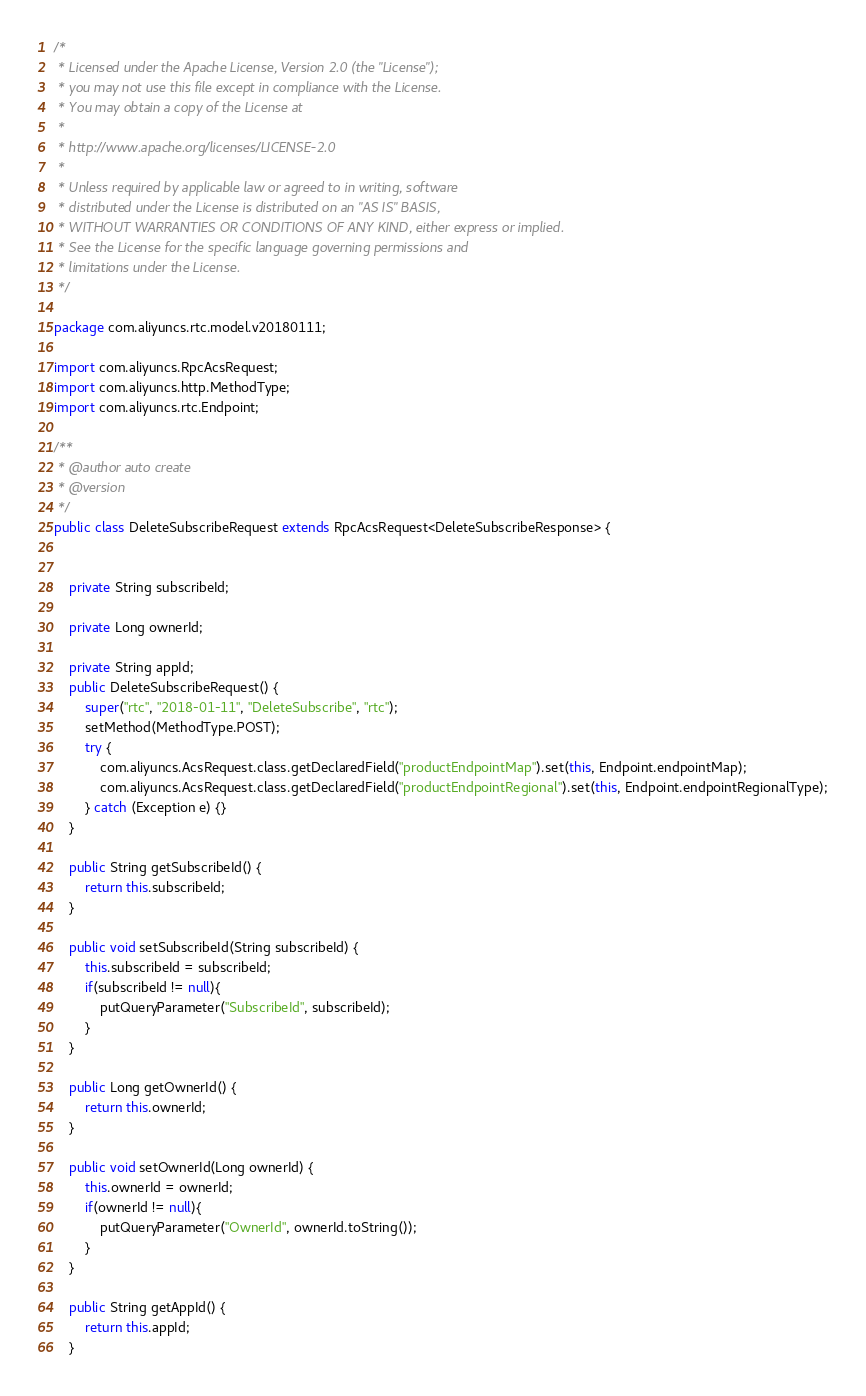Convert code to text. <code><loc_0><loc_0><loc_500><loc_500><_Java_>/*
 * Licensed under the Apache License, Version 2.0 (the "License");
 * you may not use this file except in compliance with the License.
 * You may obtain a copy of the License at
 *
 * http://www.apache.org/licenses/LICENSE-2.0
 *
 * Unless required by applicable law or agreed to in writing, software
 * distributed under the License is distributed on an "AS IS" BASIS,
 * WITHOUT WARRANTIES OR CONDITIONS OF ANY KIND, either express or implied.
 * See the License for the specific language governing permissions and
 * limitations under the License.
 */

package com.aliyuncs.rtc.model.v20180111;

import com.aliyuncs.RpcAcsRequest;
import com.aliyuncs.http.MethodType;
import com.aliyuncs.rtc.Endpoint;

/**
 * @author auto create
 * @version 
 */
public class DeleteSubscribeRequest extends RpcAcsRequest<DeleteSubscribeResponse> {
	   

	private String subscribeId;

	private Long ownerId;

	private String appId;
	public DeleteSubscribeRequest() {
		super("rtc", "2018-01-11", "DeleteSubscribe", "rtc");
		setMethod(MethodType.POST);
		try {
			com.aliyuncs.AcsRequest.class.getDeclaredField("productEndpointMap").set(this, Endpoint.endpointMap);
			com.aliyuncs.AcsRequest.class.getDeclaredField("productEndpointRegional").set(this, Endpoint.endpointRegionalType);
		} catch (Exception e) {}
	}

	public String getSubscribeId() {
		return this.subscribeId;
	}

	public void setSubscribeId(String subscribeId) {
		this.subscribeId = subscribeId;
		if(subscribeId != null){
			putQueryParameter("SubscribeId", subscribeId);
		}
	}

	public Long getOwnerId() {
		return this.ownerId;
	}

	public void setOwnerId(Long ownerId) {
		this.ownerId = ownerId;
		if(ownerId != null){
			putQueryParameter("OwnerId", ownerId.toString());
		}
	}

	public String getAppId() {
		return this.appId;
	}
</code> 